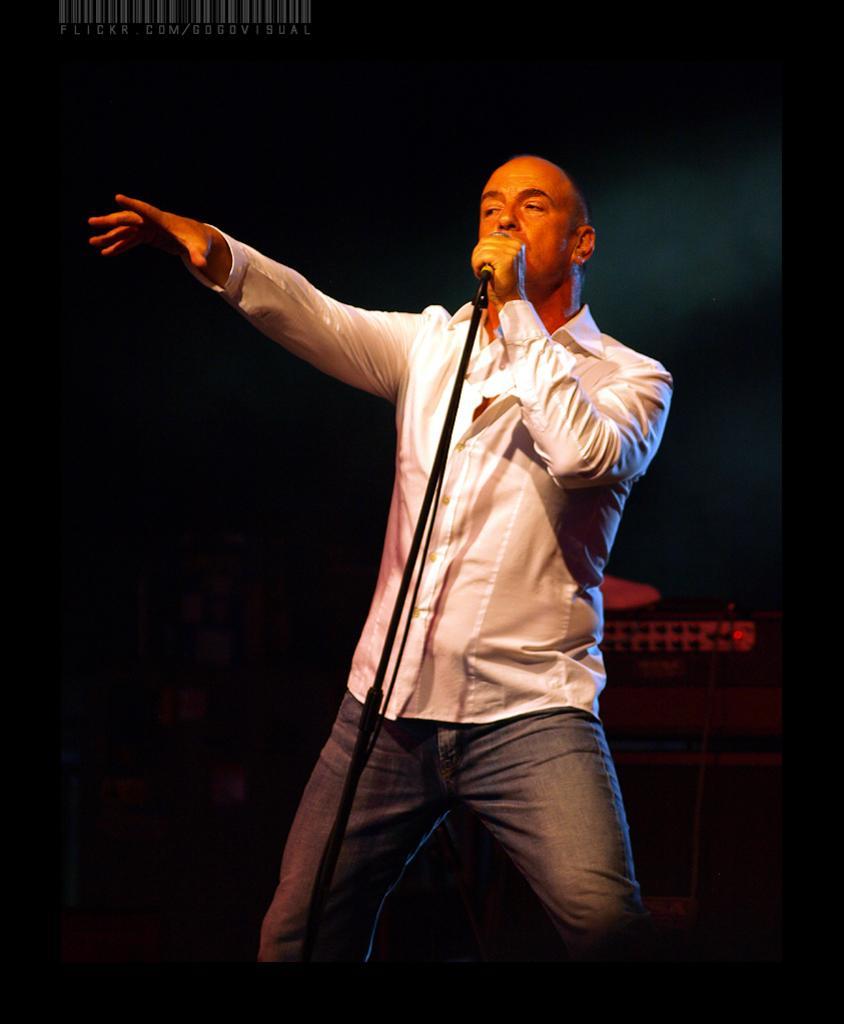Could you give a brief overview of what you see in this image? In this image we can see a person wearing a dress is holding a microphone placed on a stand. In the background, we can see a device with cable and some text. 